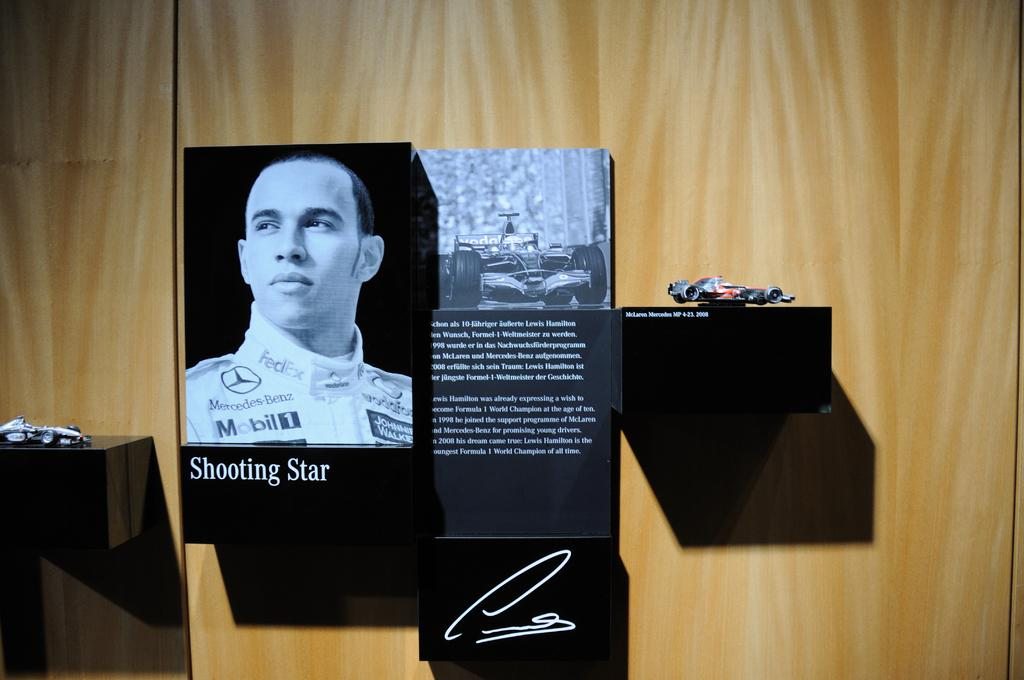What is attached to the wall in the image? There are boards on the wall in the image. What can be found on the boards? There are shelves in the image. What items are placed on the shelves? Toys are present on the shelves. What type of headwear is visible on the toys in the image? There is no headwear visible on the toys in the image. Can you describe the yard where the toys are located? There is no yard present in the image; it only shows boards on the wall with shelves and toys. 